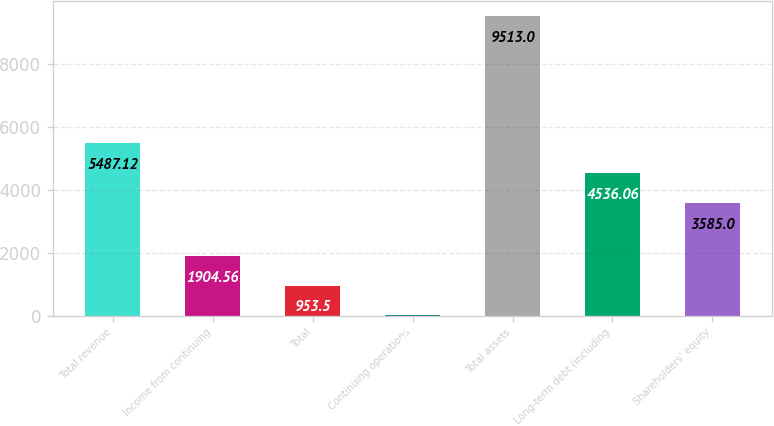Convert chart. <chart><loc_0><loc_0><loc_500><loc_500><bar_chart><fcel>Total revenue<fcel>Income from continuing<fcel>Total<fcel>Continuing operations<fcel>Total assets<fcel>Long-term debt (including<fcel>Shareholders' equity<nl><fcel>5487.12<fcel>1904.56<fcel>953.5<fcel>2.44<fcel>9513<fcel>4536.06<fcel>3585<nl></chart> 